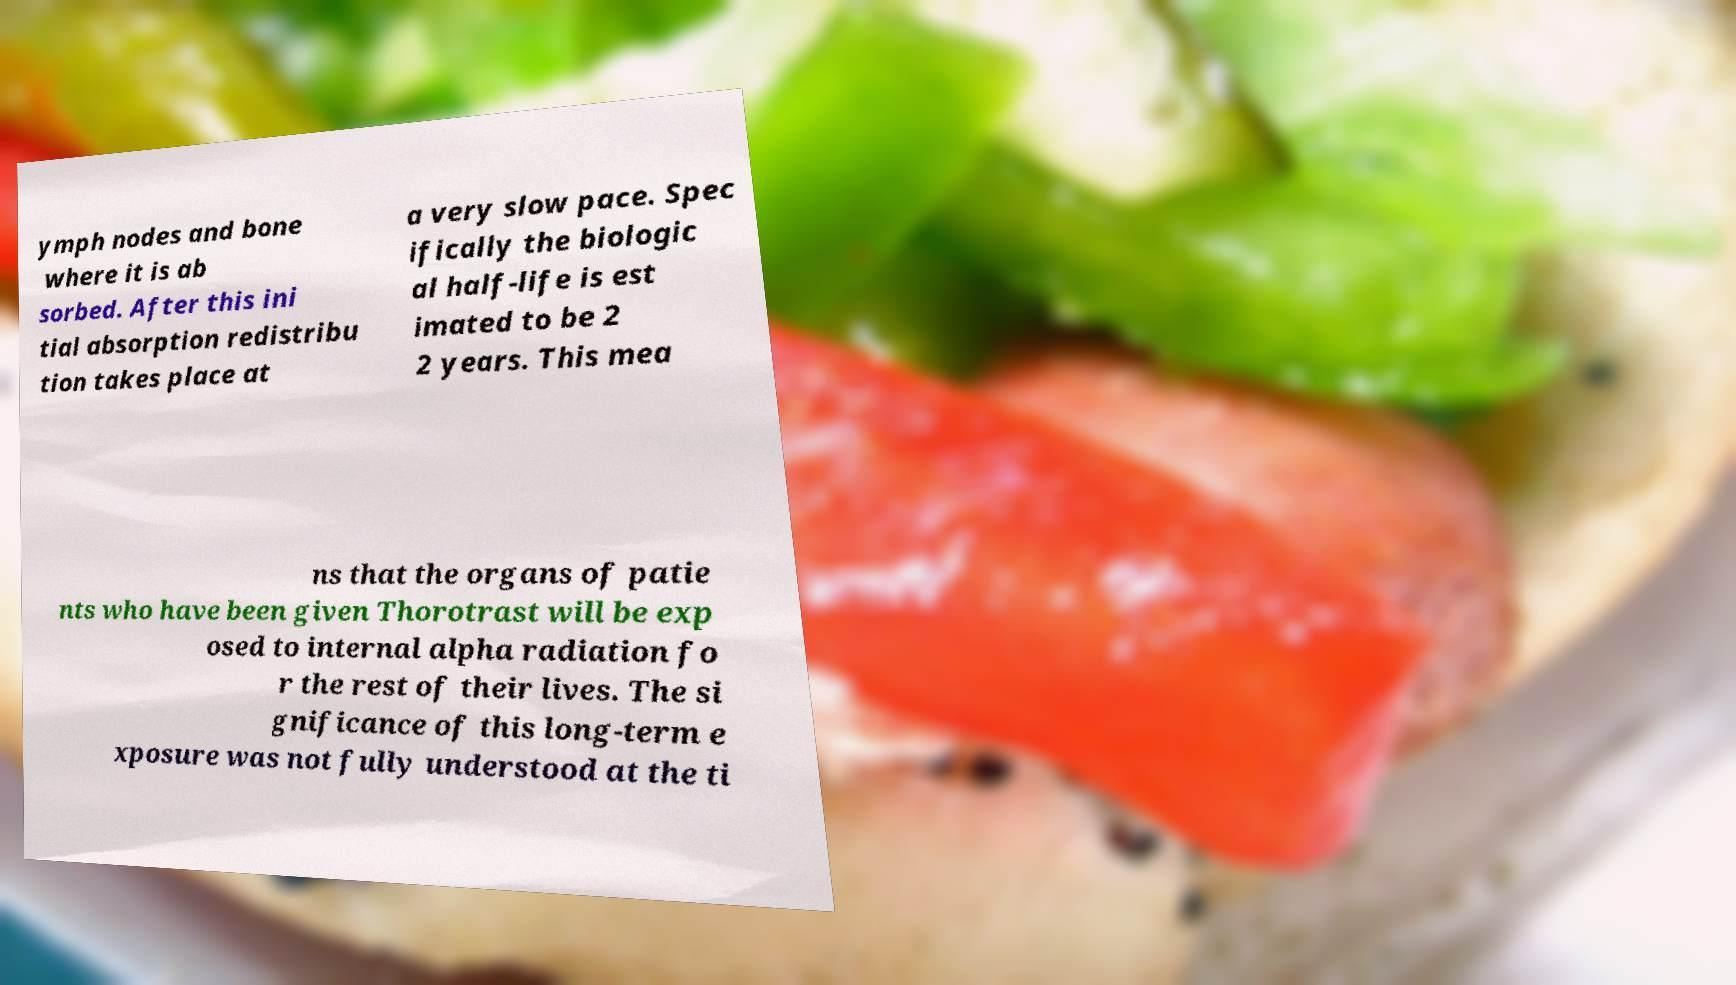Can you read and provide the text displayed in the image?This photo seems to have some interesting text. Can you extract and type it out for me? ymph nodes and bone where it is ab sorbed. After this ini tial absorption redistribu tion takes place at a very slow pace. Spec ifically the biologic al half-life is est imated to be 2 2 years. This mea ns that the organs of patie nts who have been given Thorotrast will be exp osed to internal alpha radiation fo r the rest of their lives. The si gnificance of this long-term e xposure was not fully understood at the ti 